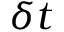<formula> <loc_0><loc_0><loc_500><loc_500>\delta t</formula> 